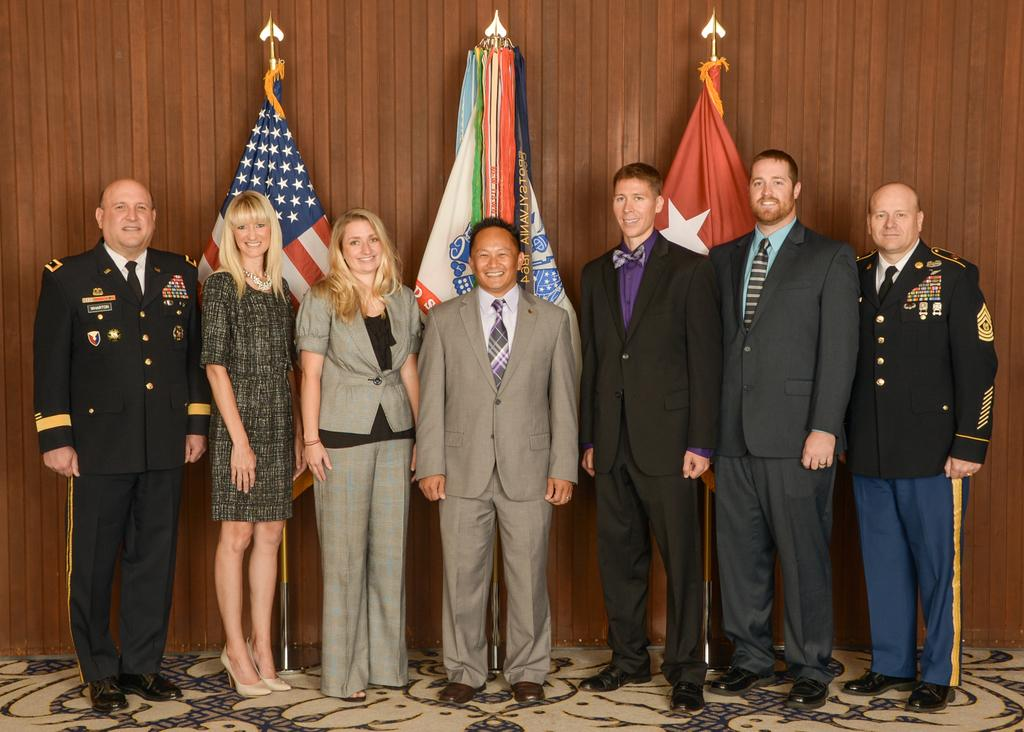What is the setting of the image? The image is likely taken inside a room. What can be seen on the floor in the image? There are people standing on the floor in the image. What is visible in the background of the image? There are three flags and a wood wall in the background of the image. What type of jam is being spread on the toad in the image? There is no toad or jam present in the image. What is the desire of the people in the image? The image does not provide information about the desires of the people; it only shows them standing on the floor. 